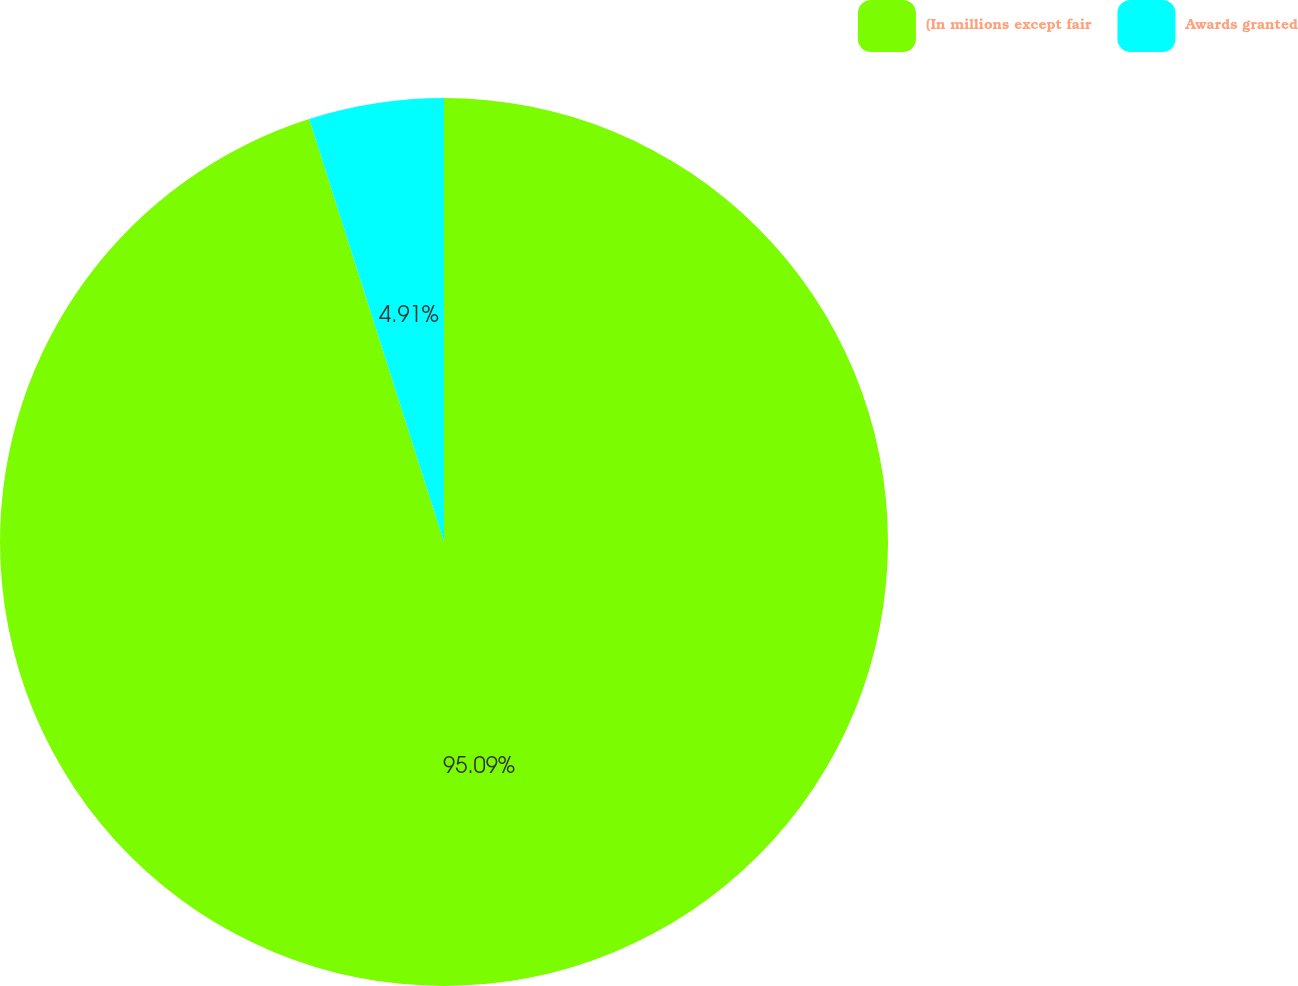Convert chart. <chart><loc_0><loc_0><loc_500><loc_500><pie_chart><fcel>(In millions except fair<fcel>Awards granted<nl><fcel>95.09%<fcel>4.91%<nl></chart> 